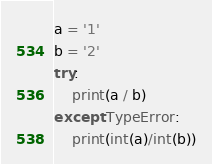<code> <loc_0><loc_0><loc_500><loc_500><_Python_>a = '1'
b = '2'
try:
    print(a / b)
except TypeError:
    print(int(a)/int(b))
</code> 